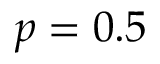Convert formula to latex. <formula><loc_0><loc_0><loc_500><loc_500>p = 0 . 5</formula> 